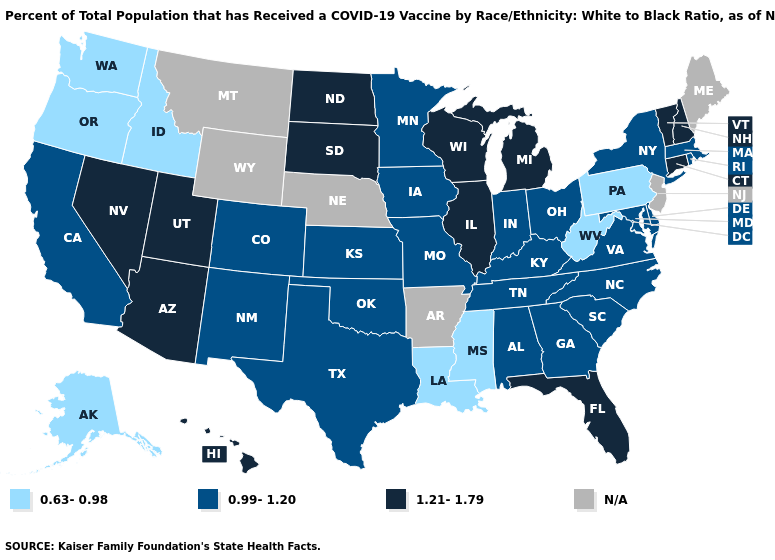What is the value of Minnesota?
Concise answer only. 0.99-1.20. What is the lowest value in the Northeast?
Concise answer only. 0.63-0.98. Does Vermont have the highest value in the Northeast?
Concise answer only. Yes. Among the states that border Pennsylvania , does Ohio have the lowest value?
Answer briefly. No. Which states hav the highest value in the Northeast?
Keep it brief. Connecticut, New Hampshire, Vermont. Name the states that have a value in the range 1.21-1.79?
Quick response, please. Arizona, Connecticut, Florida, Hawaii, Illinois, Michigan, Nevada, New Hampshire, North Dakota, South Dakota, Utah, Vermont, Wisconsin. Among the states that border Kentucky , which have the lowest value?
Short answer required. West Virginia. Does the first symbol in the legend represent the smallest category?
Answer briefly. Yes. What is the lowest value in the USA?
Concise answer only. 0.63-0.98. Which states have the lowest value in the MidWest?
Answer briefly. Indiana, Iowa, Kansas, Minnesota, Missouri, Ohio. How many symbols are there in the legend?
Answer briefly. 4. Which states have the highest value in the USA?
Concise answer only. Arizona, Connecticut, Florida, Hawaii, Illinois, Michigan, Nevada, New Hampshire, North Dakota, South Dakota, Utah, Vermont, Wisconsin. What is the value of Virginia?
Answer briefly. 0.99-1.20. What is the value of Montana?
Answer briefly. N/A. Name the states that have a value in the range 0.99-1.20?
Write a very short answer. Alabama, California, Colorado, Delaware, Georgia, Indiana, Iowa, Kansas, Kentucky, Maryland, Massachusetts, Minnesota, Missouri, New Mexico, New York, North Carolina, Ohio, Oklahoma, Rhode Island, South Carolina, Tennessee, Texas, Virginia. 